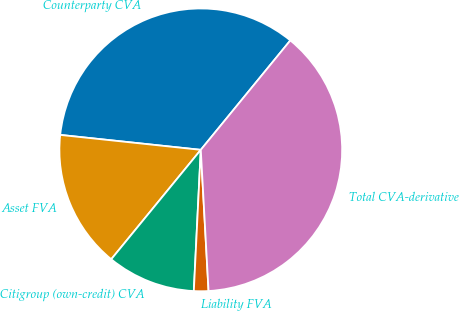Convert chart. <chart><loc_0><loc_0><loc_500><loc_500><pie_chart><fcel>Counterparty CVA<fcel>Asset FVA<fcel>Citigroup (own-credit) CVA<fcel>Liability FVA<fcel>Total CVA-derivative<nl><fcel>34.23%<fcel>15.77%<fcel>10.13%<fcel>1.66%<fcel>38.21%<nl></chart> 